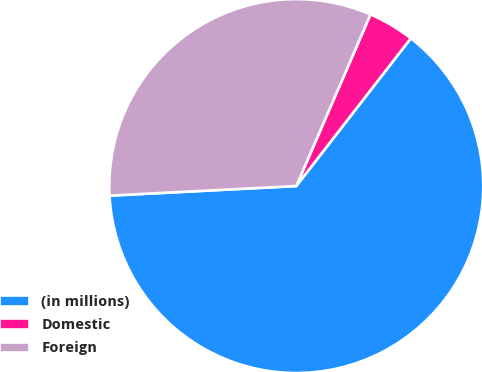Convert chart. <chart><loc_0><loc_0><loc_500><loc_500><pie_chart><fcel>(in millions)<fcel>Domestic<fcel>Foreign<nl><fcel>63.69%<fcel>4.0%<fcel>32.31%<nl></chart> 